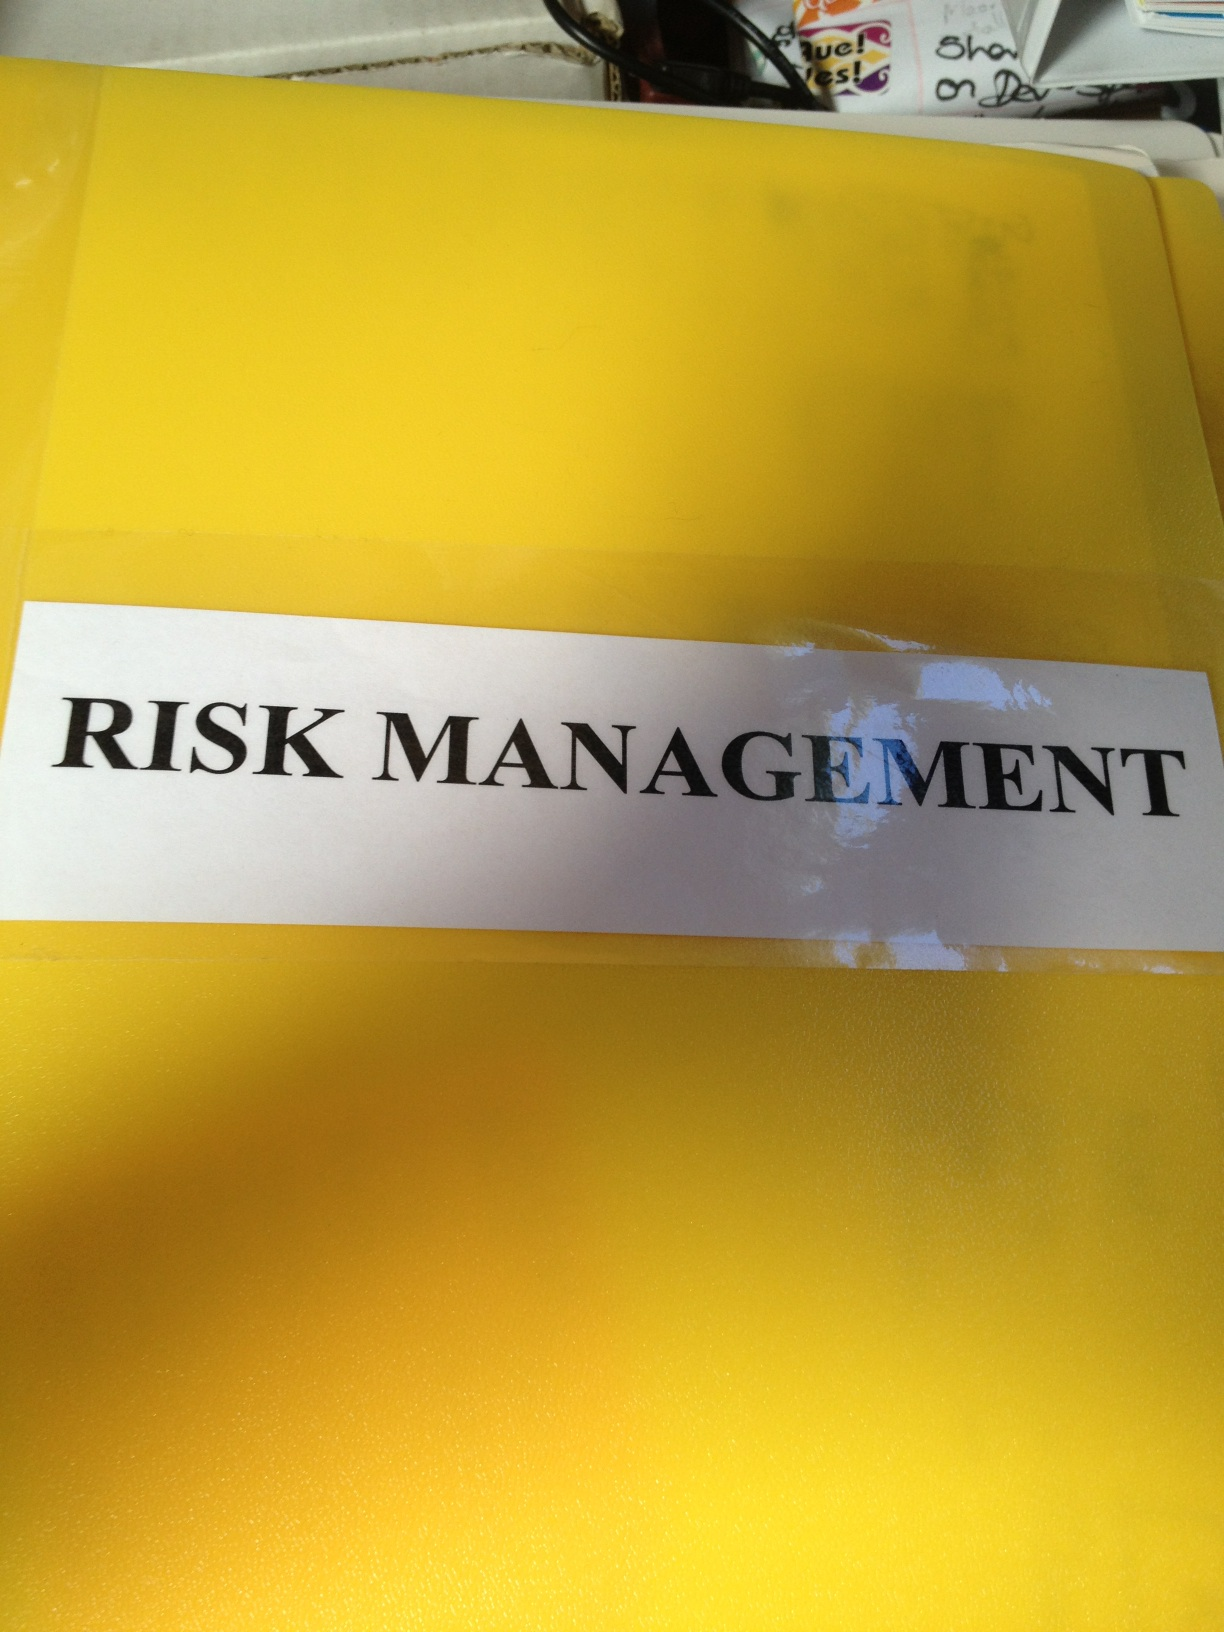Imagine this folder could speak. What story would it tell? If this folder could speak, it would tell the tale of countless hours spent analyzing, preparing, and mitigating risks in a bustling corporate environment. It would recount the endless meetings, the collaborative brainstorming sessions, and the meticulous calculations that went into safeguarding the company’s future. It would share stories of near disasters avoided thanks to diligent planning, and of the rewarding feeling that comes with securing the company's assets and reputation. This folder has witnessed sleepless nights, intense discussions, and strategic triumphs. Can you define risk management in a single sentence? Risk management is the systematic process of identifying, assessing, and mitigating threats to an organization’s capital and earnings. 